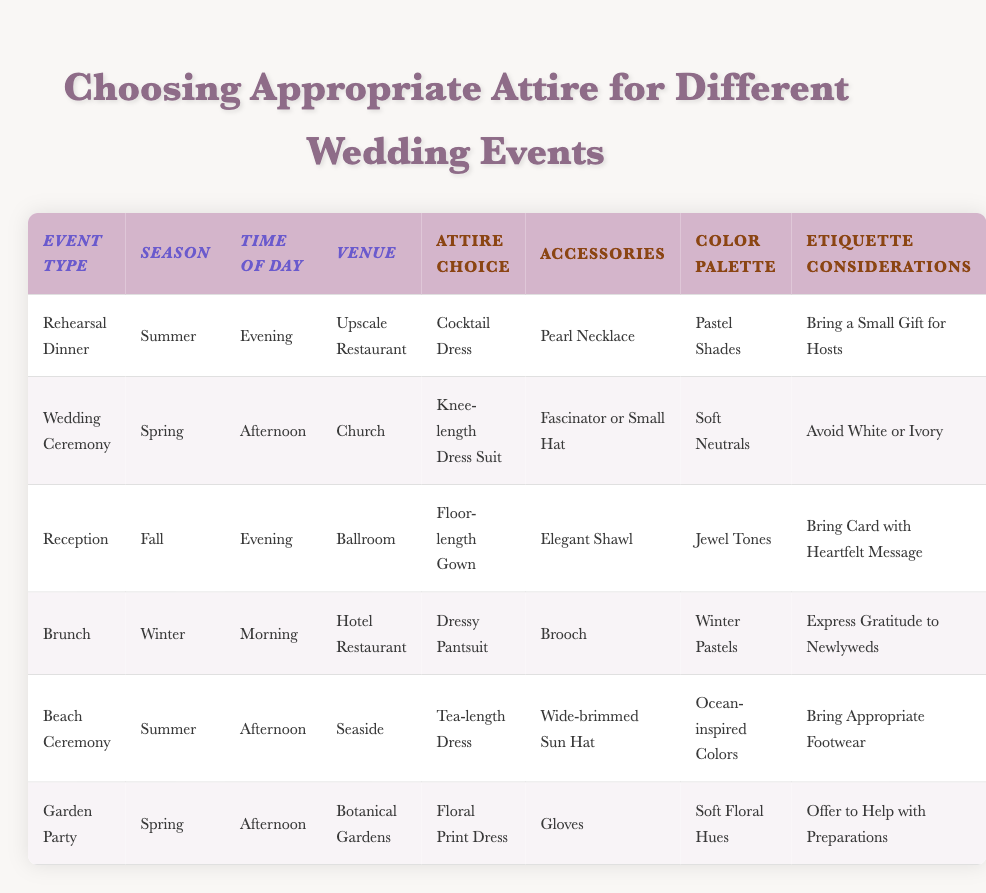What type of attire is recommended for a rehearsal dinner in the summer? The table indicates that for a Rehearsal Dinner during the summer, the recommended attire choice is a Cocktail Dress.
Answer: Cocktail Dress What accessories should be worn to the wedding ceremony? According to the table, the accessories for the Wedding Ceremony should include a Fascinator or Small Hat.
Answer: Fascinator or Small Hat Is it appropriate to wear white or ivory to a wedding ceremony? The table states it is etiquette to avoid wearing white or ivory to the Wedding Ceremony, indicating that it is not appropriate.
Answer: No What is the dress code for the reception in the fall? For the Reception in the fall, the dress code is a Floor-length Gown, as specified in the table.
Answer: Floor-length Gown Are there any events where a tea-length dress is appropriate? Yes, the Beach Ceremony in summer is the only event listed that specifies a Tea-length Dress as appropriate attire.
Answer: Yes How many events suggest wearing a floral dress? The table lists two events where a floral dress is suggested: the Garden Party with a Floral Print Dress and the Wedding Ceremony which uses a Knee-length Dress Suit (not floral). Thus, the answer is one event.
Answer: One event What color palette is recommended for the brunch in winter? The table specifies that the recommended color palette for the brunch in winter is Winter Pastels.
Answer: Winter Pastels For which wedding event should you bring a small gift for the hosts? The table indicates that for the Rehearsal Dinner, it is considered etiquette to bring a small gift for the hosts.
Answer: Rehearsal Dinner Which events occur in the afternoon? The Wedding Ceremony, Beach Ceremony, and Garden Party all take place in the afternoon, making it three events.
Answer: Three events 